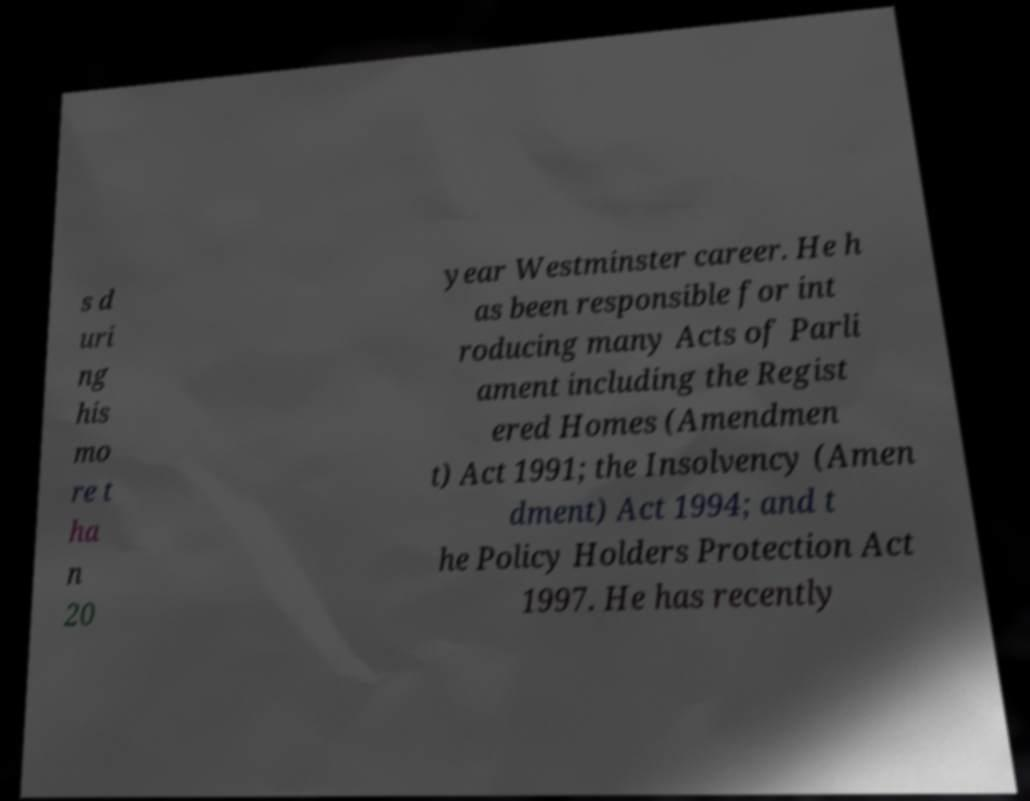For documentation purposes, I need the text within this image transcribed. Could you provide that? s d uri ng his mo re t ha n 20 year Westminster career. He h as been responsible for int roducing many Acts of Parli ament including the Regist ered Homes (Amendmen t) Act 1991; the Insolvency (Amen dment) Act 1994; and t he Policy Holders Protection Act 1997. He has recently 